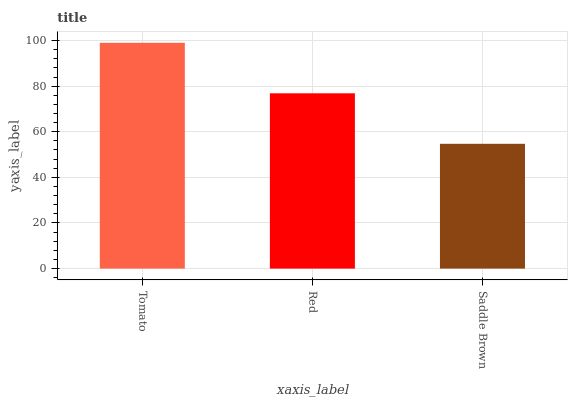Is Saddle Brown the minimum?
Answer yes or no. Yes. Is Tomato the maximum?
Answer yes or no. Yes. Is Red the minimum?
Answer yes or no. No. Is Red the maximum?
Answer yes or no. No. Is Tomato greater than Red?
Answer yes or no. Yes. Is Red less than Tomato?
Answer yes or no. Yes. Is Red greater than Tomato?
Answer yes or no. No. Is Tomato less than Red?
Answer yes or no. No. Is Red the high median?
Answer yes or no. Yes. Is Red the low median?
Answer yes or no. Yes. Is Tomato the high median?
Answer yes or no. No. Is Tomato the low median?
Answer yes or no. No. 